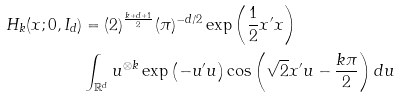<formula> <loc_0><loc_0><loc_500><loc_500>H _ { k } ( x ; 0 , I _ { d } ) & = ( 2 ) ^ { \frac { k + d + 1 } { 2 } } ( \pi ) ^ { - d / 2 } \exp \left ( \frac { 1 } { 2 } x ^ { \prime } x \right ) \\ & \int _ { \mathbb { R } ^ { d } } u ^ { \otimes k } \exp \left ( - u ^ { \prime } u \right ) \cos \left ( \sqrt { 2 } x ^ { \prime } u - \frac { k \pi } { 2 } \right ) d u</formula> 